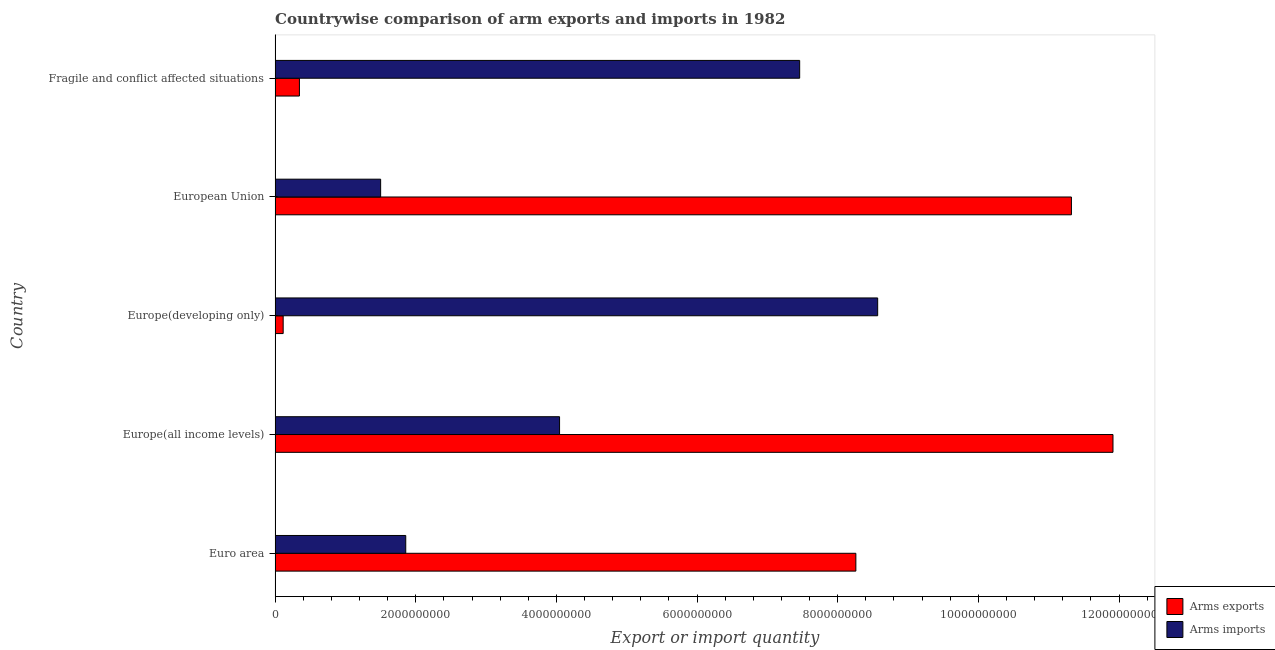How many groups of bars are there?
Make the answer very short. 5. Are the number of bars on each tick of the Y-axis equal?
Your response must be concise. Yes. How many bars are there on the 5th tick from the top?
Make the answer very short. 2. What is the label of the 5th group of bars from the top?
Ensure brevity in your answer.  Euro area. What is the arms imports in Fragile and conflict affected situations?
Your response must be concise. 7.46e+09. Across all countries, what is the maximum arms exports?
Make the answer very short. 1.19e+1. Across all countries, what is the minimum arms imports?
Your answer should be compact. 1.50e+09. In which country was the arms imports maximum?
Offer a terse response. Europe(developing only). In which country was the arms exports minimum?
Give a very brief answer. Europe(developing only). What is the total arms exports in the graph?
Offer a very short reply. 3.20e+1. What is the difference between the arms imports in Euro area and that in European Union?
Provide a short and direct response. 3.57e+08. What is the difference between the arms imports in Europe(all income levels) and the arms exports in Euro area?
Your answer should be very brief. -4.21e+09. What is the average arms imports per country?
Offer a terse response. 4.69e+09. What is the difference between the arms exports and arms imports in Euro area?
Your response must be concise. 6.40e+09. What is the ratio of the arms imports in Europe(all income levels) to that in Fragile and conflict affected situations?
Provide a short and direct response. 0.54. Is the arms imports in Europe(all income levels) less than that in European Union?
Keep it short and to the point. No. Is the difference between the arms imports in European Union and Fragile and conflict affected situations greater than the difference between the arms exports in European Union and Fragile and conflict affected situations?
Provide a short and direct response. No. What is the difference between the highest and the second highest arms exports?
Ensure brevity in your answer.  5.91e+08. What is the difference between the highest and the lowest arms imports?
Your answer should be compact. 7.07e+09. In how many countries, is the arms exports greater than the average arms exports taken over all countries?
Provide a succinct answer. 3. Is the sum of the arms imports in European Union and Fragile and conflict affected situations greater than the maximum arms exports across all countries?
Ensure brevity in your answer.  No. What does the 2nd bar from the top in Fragile and conflict affected situations represents?
Offer a terse response. Arms exports. What does the 2nd bar from the bottom in Fragile and conflict affected situations represents?
Your answer should be compact. Arms imports. How many countries are there in the graph?
Make the answer very short. 5. What is the difference between two consecutive major ticks on the X-axis?
Your answer should be very brief. 2.00e+09. Does the graph contain any zero values?
Give a very brief answer. No. Does the graph contain grids?
Make the answer very short. No. How many legend labels are there?
Keep it short and to the point. 2. How are the legend labels stacked?
Make the answer very short. Vertical. What is the title of the graph?
Your answer should be compact. Countrywise comparison of arm exports and imports in 1982. What is the label or title of the X-axis?
Your answer should be compact. Export or import quantity. What is the Export or import quantity of Arms exports in Euro area?
Your response must be concise. 8.26e+09. What is the Export or import quantity in Arms imports in Euro area?
Make the answer very short. 1.86e+09. What is the Export or import quantity in Arms exports in Europe(all income levels)?
Ensure brevity in your answer.  1.19e+1. What is the Export or import quantity in Arms imports in Europe(all income levels)?
Your answer should be very brief. 4.04e+09. What is the Export or import quantity of Arms exports in Europe(developing only)?
Give a very brief answer. 1.15e+08. What is the Export or import quantity of Arms imports in Europe(developing only)?
Provide a short and direct response. 8.57e+09. What is the Export or import quantity of Arms exports in European Union?
Ensure brevity in your answer.  1.13e+1. What is the Export or import quantity of Arms imports in European Union?
Offer a very short reply. 1.50e+09. What is the Export or import quantity in Arms exports in Fragile and conflict affected situations?
Make the answer very short. 3.46e+08. What is the Export or import quantity of Arms imports in Fragile and conflict affected situations?
Keep it short and to the point. 7.46e+09. Across all countries, what is the maximum Export or import quantity of Arms exports?
Ensure brevity in your answer.  1.19e+1. Across all countries, what is the maximum Export or import quantity in Arms imports?
Keep it short and to the point. 8.57e+09. Across all countries, what is the minimum Export or import quantity in Arms exports?
Provide a short and direct response. 1.15e+08. Across all countries, what is the minimum Export or import quantity in Arms imports?
Keep it short and to the point. 1.50e+09. What is the total Export or import quantity in Arms exports in the graph?
Your response must be concise. 3.20e+1. What is the total Export or import quantity of Arms imports in the graph?
Provide a short and direct response. 2.34e+1. What is the difference between the Export or import quantity in Arms exports in Euro area and that in Europe(all income levels)?
Your response must be concise. -3.66e+09. What is the difference between the Export or import quantity in Arms imports in Euro area and that in Europe(all income levels)?
Offer a terse response. -2.19e+09. What is the difference between the Export or import quantity of Arms exports in Euro area and that in Europe(developing only)?
Offer a terse response. 8.14e+09. What is the difference between the Export or import quantity in Arms imports in Euro area and that in Europe(developing only)?
Your response must be concise. -6.71e+09. What is the difference between the Export or import quantity of Arms exports in Euro area and that in European Union?
Your response must be concise. -3.06e+09. What is the difference between the Export or import quantity in Arms imports in Euro area and that in European Union?
Ensure brevity in your answer.  3.57e+08. What is the difference between the Export or import quantity in Arms exports in Euro area and that in Fragile and conflict affected situations?
Provide a succinct answer. 7.91e+09. What is the difference between the Export or import quantity of Arms imports in Euro area and that in Fragile and conflict affected situations?
Make the answer very short. -5.60e+09. What is the difference between the Export or import quantity in Arms exports in Europe(all income levels) and that in Europe(developing only)?
Provide a succinct answer. 1.18e+1. What is the difference between the Export or import quantity in Arms imports in Europe(all income levels) and that in Europe(developing only)?
Your answer should be compact. -4.52e+09. What is the difference between the Export or import quantity of Arms exports in Europe(all income levels) and that in European Union?
Your answer should be very brief. 5.91e+08. What is the difference between the Export or import quantity of Arms imports in Europe(all income levels) and that in European Union?
Give a very brief answer. 2.54e+09. What is the difference between the Export or import quantity of Arms exports in Europe(all income levels) and that in Fragile and conflict affected situations?
Provide a short and direct response. 1.16e+1. What is the difference between the Export or import quantity in Arms imports in Europe(all income levels) and that in Fragile and conflict affected situations?
Your response must be concise. -3.41e+09. What is the difference between the Export or import quantity in Arms exports in Europe(developing only) and that in European Union?
Offer a terse response. -1.12e+1. What is the difference between the Export or import quantity of Arms imports in Europe(developing only) and that in European Union?
Your answer should be compact. 7.07e+09. What is the difference between the Export or import quantity in Arms exports in Europe(developing only) and that in Fragile and conflict affected situations?
Offer a terse response. -2.31e+08. What is the difference between the Export or import quantity in Arms imports in Europe(developing only) and that in Fragile and conflict affected situations?
Offer a terse response. 1.11e+09. What is the difference between the Export or import quantity of Arms exports in European Union and that in Fragile and conflict affected situations?
Give a very brief answer. 1.10e+1. What is the difference between the Export or import quantity in Arms imports in European Union and that in Fragile and conflict affected situations?
Make the answer very short. -5.96e+09. What is the difference between the Export or import quantity in Arms exports in Euro area and the Export or import quantity in Arms imports in Europe(all income levels)?
Make the answer very short. 4.21e+09. What is the difference between the Export or import quantity in Arms exports in Euro area and the Export or import quantity in Arms imports in Europe(developing only)?
Keep it short and to the point. -3.10e+08. What is the difference between the Export or import quantity of Arms exports in Euro area and the Export or import quantity of Arms imports in European Union?
Offer a terse response. 6.76e+09. What is the difference between the Export or import quantity in Arms exports in Euro area and the Export or import quantity in Arms imports in Fragile and conflict affected situations?
Offer a terse response. 7.99e+08. What is the difference between the Export or import quantity in Arms exports in Europe(all income levels) and the Export or import quantity in Arms imports in Europe(developing only)?
Offer a very short reply. 3.35e+09. What is the difference between the Export or import quantity in Arms exports in Europe(all income levels) and the Export or import quantity in Arms imports in European Union?
Your response must be concise. 1.04e+1. What is the difference between the Export or import quantity in Arms exports in Europe(all income levels) and the Export or import quantity in Arms imports in Fragile and conflict affected situations?
Provide a short and direct response. 4.46e+09. What is the difference between the Export or import quantity of Arms exports in Europe(developing only) and the Export or import quantity of Arms imports in European Union?
Keep it short and to the point. -1.39e+09. What is the difference between the Export or import quantity in Arms exports in Europe(developing only) and the Export or import quantity in Arms imports in Fragile and conflict affected situations?
Make the answer very short. -7.34e+09. What is the difference between the Export or import quantity of Arms exports in European Union and the Export or import quantity of Arms imports in Fragile and conflict affected situations?
Give a very brief answer. 3.86e+09. What is the average Export or import quantity of Arms exports per country?
Your answer should be very brief. 6.39e+09. What is the average Export or import quantity in Arms imports per country?
Provide a succinct answer. 4.69e+09. What is the difference between the Export or import quantity in Arms exports and Export or import quantity in Arms imports in Euro area?
Offer a very short reply. 6.40e+09. What is the difference between the Export or import quantity in Arms exports and Export or import quantity in Arms imports in Europe(all income levels)?
Your answer should be compact. 7.87e+09. What is the difference between the Export or import quantity of Arms exports and Export or import quantity of Arms imports in Europe(developing only)?
Ensure brevity in your answer.  -8.45e+09. What is the difference between the Export or import quantity of Arms exports and Export or import quantity of Arms imports in European Union?
Your response must be concise. 9.82e+09. What is the difference between the Export or import quantity in Arms exports and Export or import quantity in Arms imports in Fragile and conflict affected situations?
Keep it short and to the point. -7.11e+09. What is the ratio of the Export or import quantity of Arms exports in Euro area to that in Europe(all income levels)?
Your answer should be compact. 0.69. What is the ratio of the Export or import quantity in Arms imports in Euro area to that in Europe(all income levels)?
Your answer should be very brief. 0.46. What is the ratio of the Export or import quantity of Arms exports in Euro area to that in Europe(developing only)?
Offer a terse response. 71.81. What is the ratio of the Export or import quantity of Arms imports in Euro area to that in Europe(developing only)?
Make the answer very short. 0.22. What is the ratio of the Export or import quantity in Arms exports in Euro area to that in European Union?
Make the answer very short. 0.73. What is the ratio of the Export or import quantity in Arms imports in Euro area to that in European Union?
Keep it short and to the point. 1.24. What is the ratio of the Export or import quantity in Arms exports in Euro area to that in Fragile and conflict affected situations?
Your answer should be compact. 23.87. What is the ratio of the Export or import quantity of Arms imports in Euro area to that in Fragile and conflict affected situations?
Provide a short and direct response. 0.25. What is the ratio of the Export or import quantity in Arms exports in Europe(all income levels) to that in Europe(developing only)?
Your response must be concise. 103.6. What is the ratio of the Export or import quantity of Arms imports in Europe(all income levels) to that in Europe(developing only)?
Offer a very short reply. 0.47. What is the ratio of the Export or import quantity of Arms exports in Europe(all income levels) to that in European Union?
Offer a terse response. 1.05. What is the ratio of the Export or import quantity in Arms imports in Europe(all income levels) to that in European Union?
Your answer should be compact. 2.69. What is the ratio of the Export or import quantity of Arms exports in Europe(all income levels) to that in Fragile and conflict affected situations?
Make the answer very short. 34.43. What is the ratio of the Export or import quantity in Arms imports in Europe(all income levels) to that in Fragile and conflict affected situations?
Your answer should be compact. 0.54. What is the ratio of the Export or import quantity in Arms exports in Europe(developing only) to that in European Union?
Give a very brief answer. 0.01. What is the ratio of the Export or import quantity of Arms imports in Europe(developing only) to that in European Union?
Offer a terse response. 5.71. What is the ratio of the Export or import quantity of Arms exports in Europe(developing only) to that in Fragile and conflict affected situations?
Make the answer very short. 0.33. What is the ratio of the Export or import quantity of Arms imports in Europe(developing only) to that in Fragile and conflict affected situations?
Ensure brevity in your answer.  1.15. What is the ratio of the Export or import quantity of Arms exports in European Union to that in Fragile and conflict affected situations?
Provide a short and direct response. 32.73. What is the ratio of the Export or import quantity of Arms imports in European Union to that in Fragile and conflict affected situations?
Keep it short and to the point. 0.2. What is the difference between the highest and the second highest Export or import quantity of Arms exports?
Keep it short and to the point. 5.91e+08. What is the difference between the highest and the second highest Export or import quantity in Arms imports?
Give a very brief answer. 1.11e+09. What is the difference between the highest and the lowest Export or import quantity of Arms exports?
Offer a terse response. 1.18e+1. What is the difference between the highest and the lowest Export or import quantity of Arms imports?
Offer a very short reply. 7.07e+09. 